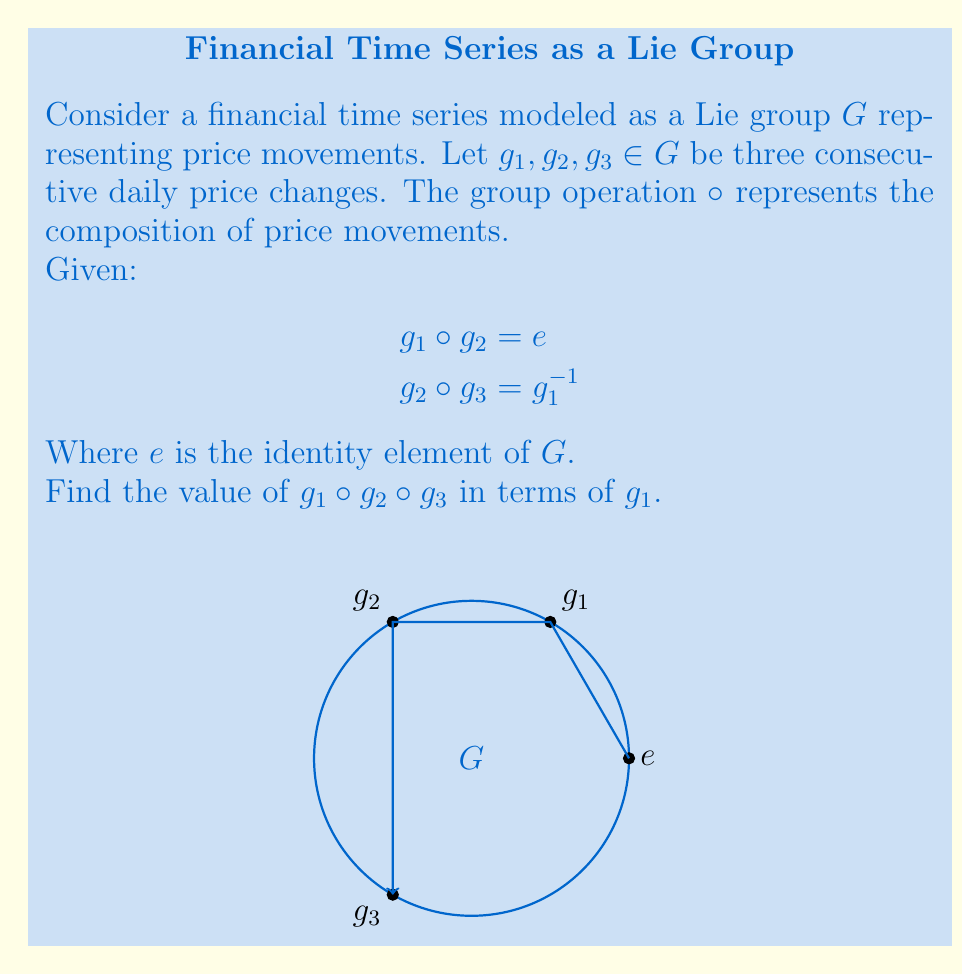Teach me how to tackle this problem. Let's approach this step-by-step:

1) First, recall that in a Lie group, the group operation is associative. This means we can evaluate the expression $g_1 \circ g_2 \circ g_3$ in any order of pairwise operations.

2) We're given that $g_1 \circ g_2 = e$. Let's use this:
   $g_1 \circ g_2 \circ g_3 = (g_1 \circ g_2) \circ g_3 = e \circ g_3 = g_3$

3) Now, we're also given that $g_2 \circ g_3 = g_1^{-1}$. Let's use this information:
   $g_1 \circ (g_2 \circ g_3) = g_1 \circ g_1^{-1}$

4) In any group, an element multiplied by its inverse gives the identity:
   $g_1 \circ g_1^{-1} = e$

5) Therefore, we have shown that:
   $g_1 \circ g_2 \circ g_3 = e$

This result makes sense in the context of financial time series. If $g_1$ and $g_2$ cancel each other out (their composition is the identity), and $g_2$ and $g_3$ together are the inverse of $g_1$, then the overall effect of all three movements should be no change at all, which is represented by the identity element.
Answer: $e$ 